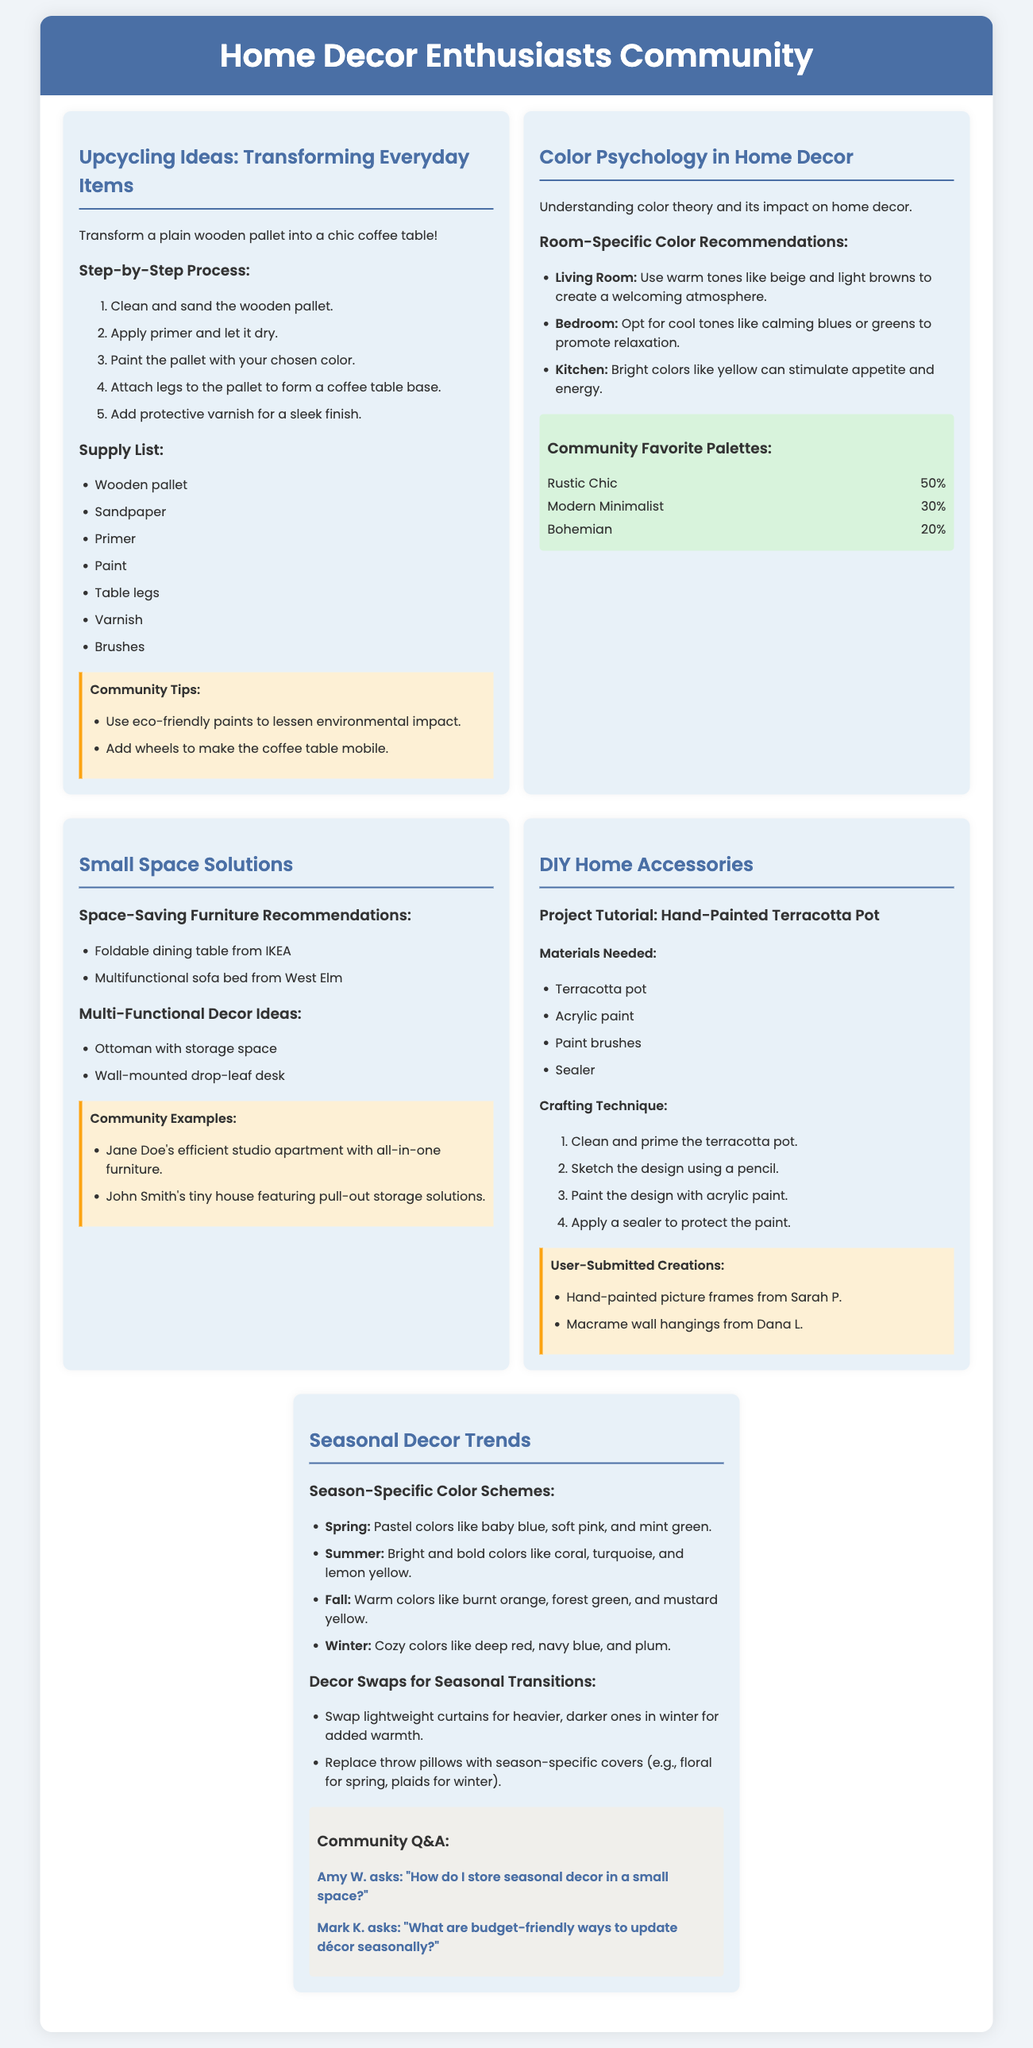What is the main project featured in the Upcycling Ideas section? The main project featured is transforming a wooden pallet into a coffee table.
Answer: wooden pallet into a coffee table How many steps are listed in the step-by-step process for the Upcycling Ideas? The step-by-step process includes five distinct stages.
Answer: 5 What are the community's two favorite decor styles from the Color Psychology section? The poll shows that Rustic Chic is at 50% and Modern Minimalist at 30%.
Answer: Rustic Chic and Modern Minimalist What is one of the examples of multi-functional decor offered in the Small Space Solutions? The document mentions using an ottoman with storage space as an example.
Answer: ottoman with storage space What seasonal color is recommended for Fall decor? The recommended color for Fall is burnt orange.
Answer: burnt orange In the DIY Home Accessories, what is one material required for the project tutorial? The materials checklist includes terracotta pot among other supplies.
Answer: terracotta pot How many seasonal color schemes are presented in the Seasonal Decor Trends section? The document outlines four distinct seasonal color schemes.
Answer: 4 What type of community interaction is included in the Seasonal Decor Trends section? The section features a community Q&A format with questions from community members.
Answer: Community Q&A What crafting technique is suggested for the hand-painted terracotta pot? The crafting technique includes cleaning and priming the terracotta pot.
Answer: cleaning and priming 